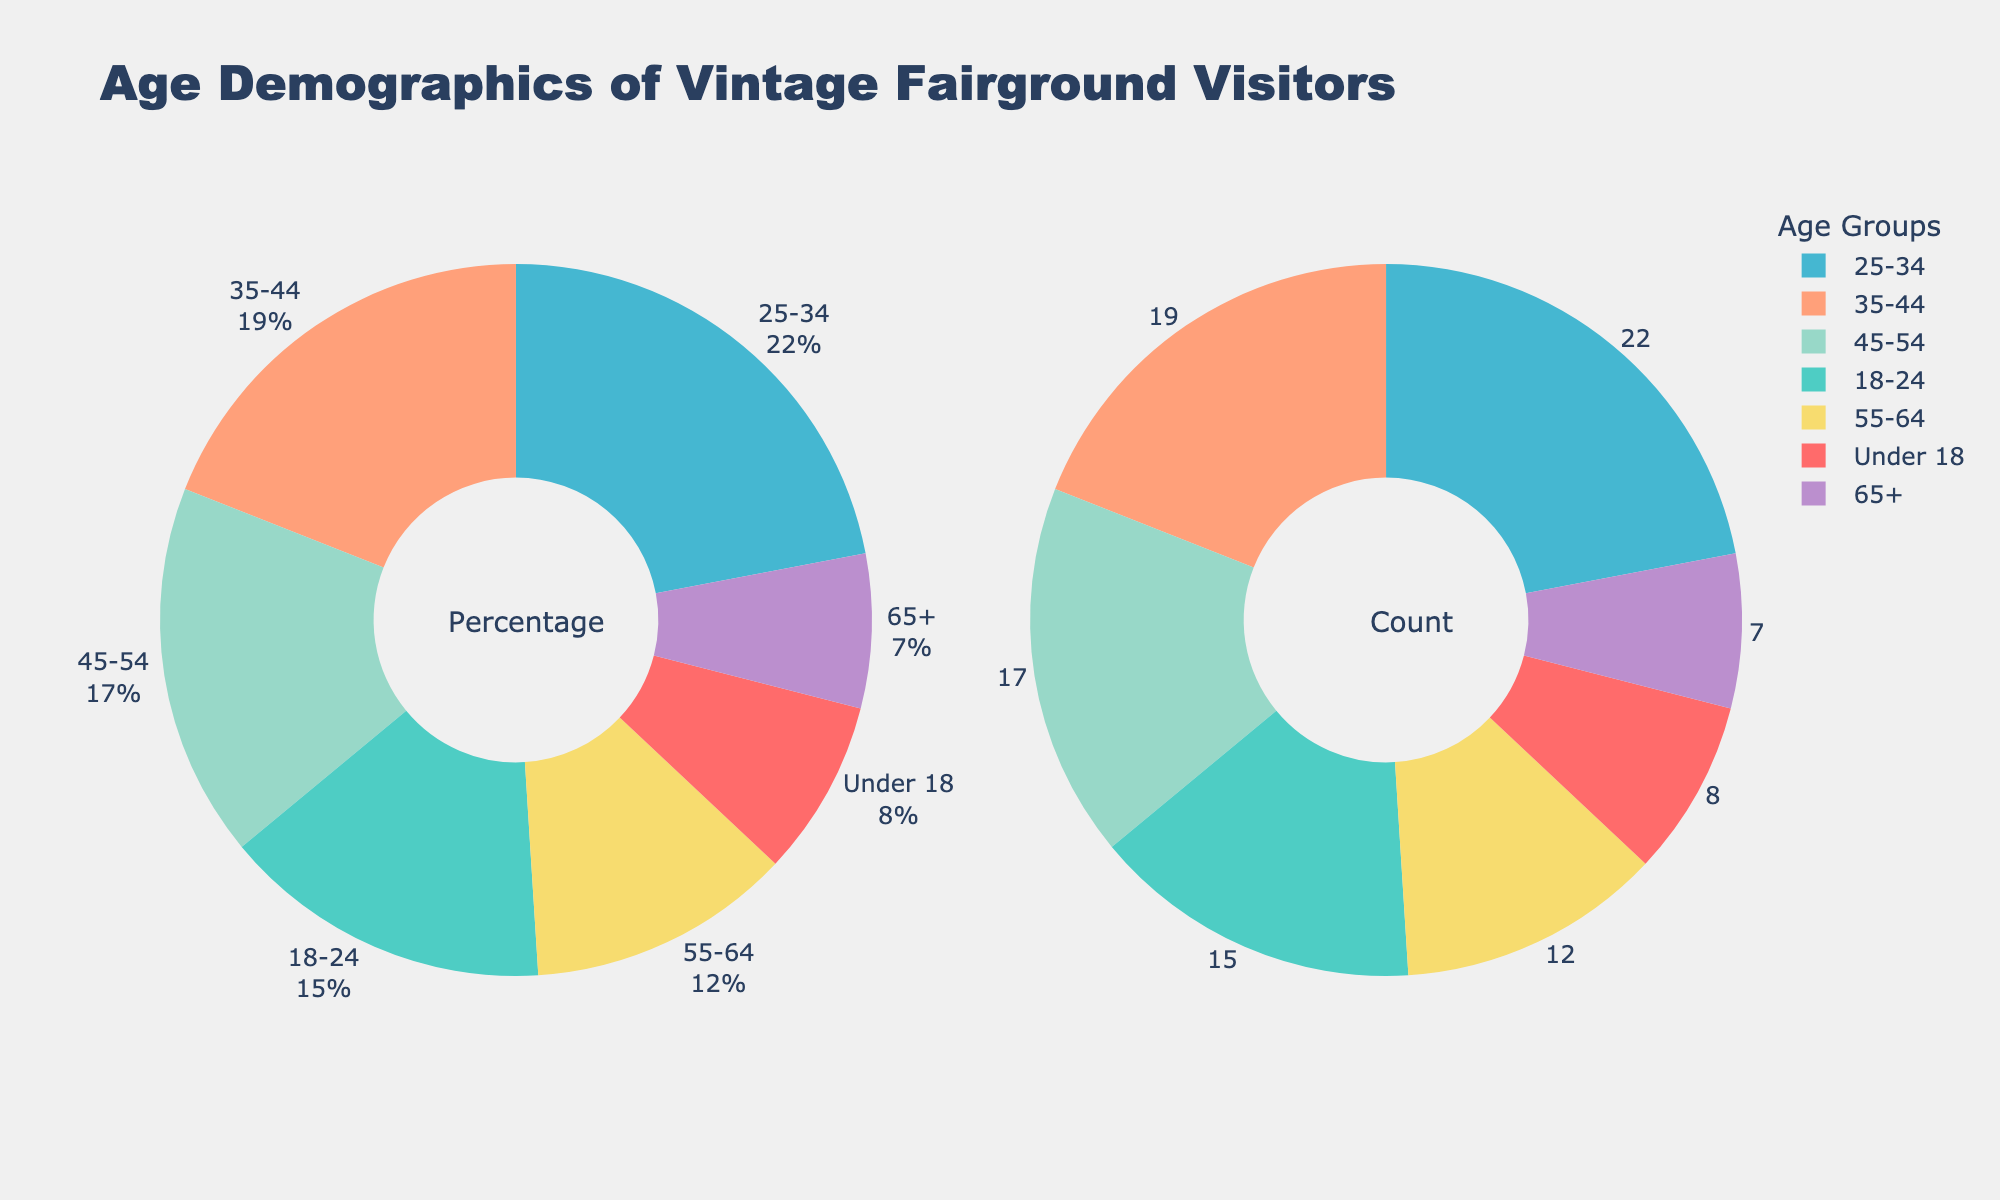Which age group forms the largest percentage of visitors? Look at the segments in the pie chart to identify the largest one based on percentage. The age group 25-34 occupies the largest segment.
Answer: 25-34 What is the total percentage of visitors aged 35 and above? Add the percentages of the age groups 35-44, 45-54, 55-64, and 65+. (19% + 17% + 12% + 7%) = 55%.
Answer: 55% How does the percentage of visitors aged 18-24 compare to those aged 45-54? Compare the values of the two age groups. 18-24 has 15%, and 45-54 has 17%, so 45-54 has a higher percentage.
Answer: 45-54 is higher Which age group has the smallest percentage of visitors, and what is that percentage? Identify the smallest segment in the pie chart. The age group 65+ has the smallest segment with 7%.
Answer: 65+, 7% What is the difference in the percentage of visitors between the age groups 25-34 and 55-64? Subtract the percentage of the 55-64 age group from that of the 25-34 age group. (22% - 12%) = 10%.
Answer: 10% What percentage of visitors are under 25? Add the percentages of the age groups Under 18 and 18-24. (8% + 15%) = 23%.
Answer: 23% Which age group is represented by a light green color, and what percentage does it have? Look at the color legend to find the group with light green. The age group 18-24 is light green and has 15%.
Answer: 18-24, 15% How many age groups have a percentage above 20%? Identify age groups with percentages greater than 20%. Only the age group 25-34 has 22%.
Answer: 1 Describe the distribution of visitors aged under 18 visually. Look for the under 18 section to understand its size relative to the whole. It's small with only 8%, taking up a small segment of the pie.
Answer: Small, 8% If the percentage of visitors aged 55-64 increased by 3%, what would be the new value and its impact on the total over 35? Add 3% to the 55-64 group and recalculate the total for those aged 35 and above. New value: 12% + 3% = 15%. New total for 35 and above: 15% + 19% + 17% + 7% = 58%.
Answer: 15%, 58% 